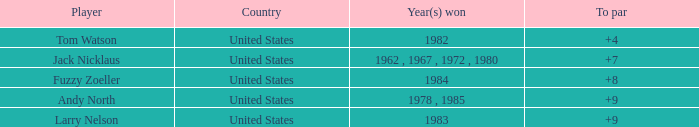What is the sum for the player with a to par of 4? 1.0. 